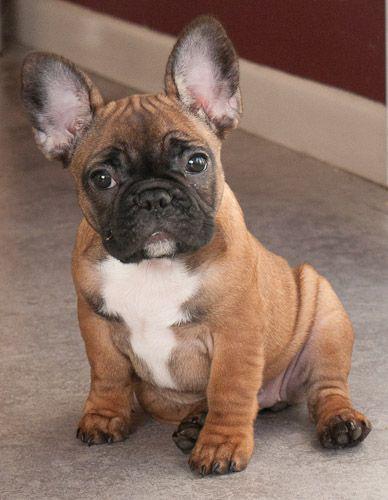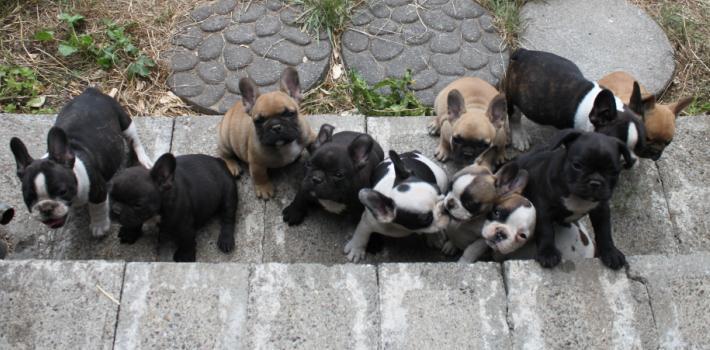The first image is the image on the left, the second image is the image on the right. Examine the images to the left and right. Is the description "There are no more than five dogs" accurate? Answer yes or no. No. The first image is the image on the left, the second image is the image on the right. For the images shown, is this caption "An image shows a row of at least 8 dogs on a cement step." true? Answer yes or no. Yes. 